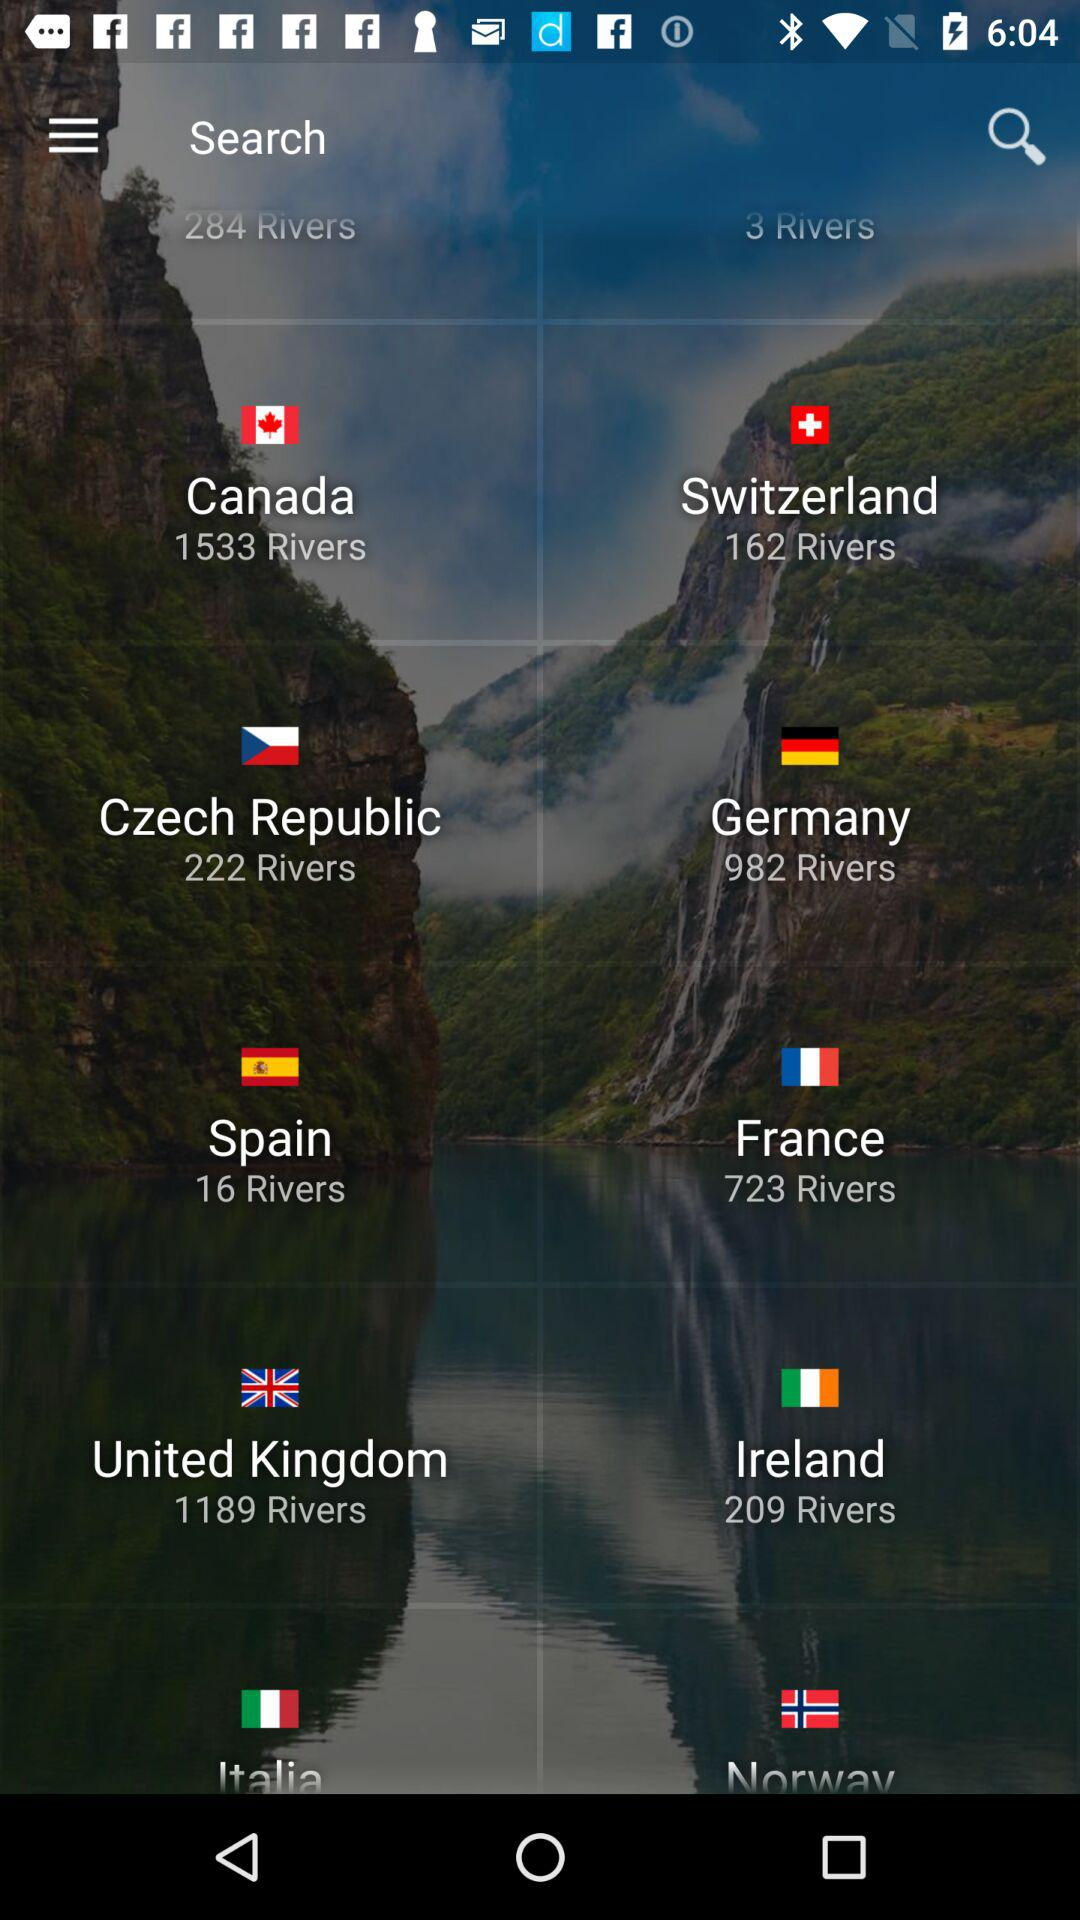How many rivers in total are there in Canada? There are 1533 rivers. 